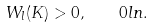Convert formula to latex. <formula><loc_0><loc_0><loc_500><loc_500>W _ { l } ( K ) > 0 , \quad 0 l n .</formula> 